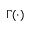Convert formula to latex. <formula><loc_0><loc_0><loc_500><loc_500>\Gamma ( \cdot )</formula> 